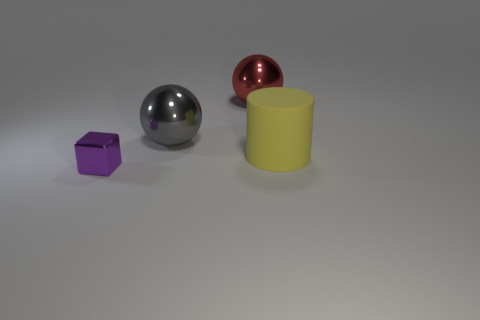Is there anything else that has the same material as the large cylinder?
Provide a short and direct response. No. There is a shiny thing in front of the matte cylinder; is there a tiny metal object that is behind it?
Provide a short and direct response. No. There is a shiny thing that is in front of the large gray sphere; what is its shape?
Your answer should be compact. Cube. What is the color of the big object on the left side of the metallic sphere on the right side of the big gray metal ball?
Your response must be concise. Gray. Is the size of the yellow matte thing the same as the red metal ball?
Your answer should be compact. Yes. There is a gray thing that is the same shape as the large red thing; what is its material?
Your answer should be very brief. Metal. What number of purple cubes have the same size as the gray metal object?
Give a very brief answer. 0. There is another large thing that is the same material as the big gray object; what color is it?
Your response must be concise. Red. Are there fewer spheres than rubber cylinders?
Offer a terse response. No. How many brown things are either big rubber cylinders or small objects?
Provide a succinct answer. 0. 